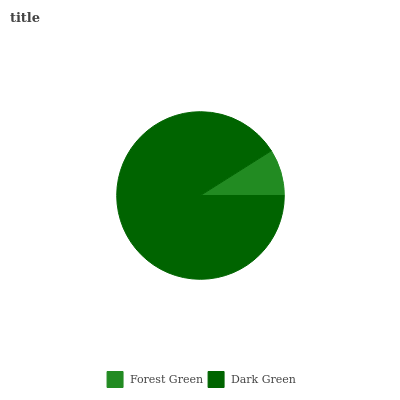Is Forest Green the minimum?
Answer yes or no. Yes. Is Dark Green the maximum?
Answer yes or no. Yes. Is Dark Green the minimum?
Answer yes or no. No. Is Dark Green greater than Forest Green?
Answer yes or no. Yes. Is Forest Green less than Dark Green?
Answer yes or no. Yes. Is Forest Green greater than Dark Green?
Answer yes or no. No. Is Dark Green less than Forest Green?
Answer yes or no. No. Is Dark Green the high median?
Answer yes or no. Yes. Is Forest Green the low median?
Answer yes or no. Yes. Is Forest Green the high median?
Answer yes or no. No. Is Dark Green the low median?
Answer yes or no. No. 